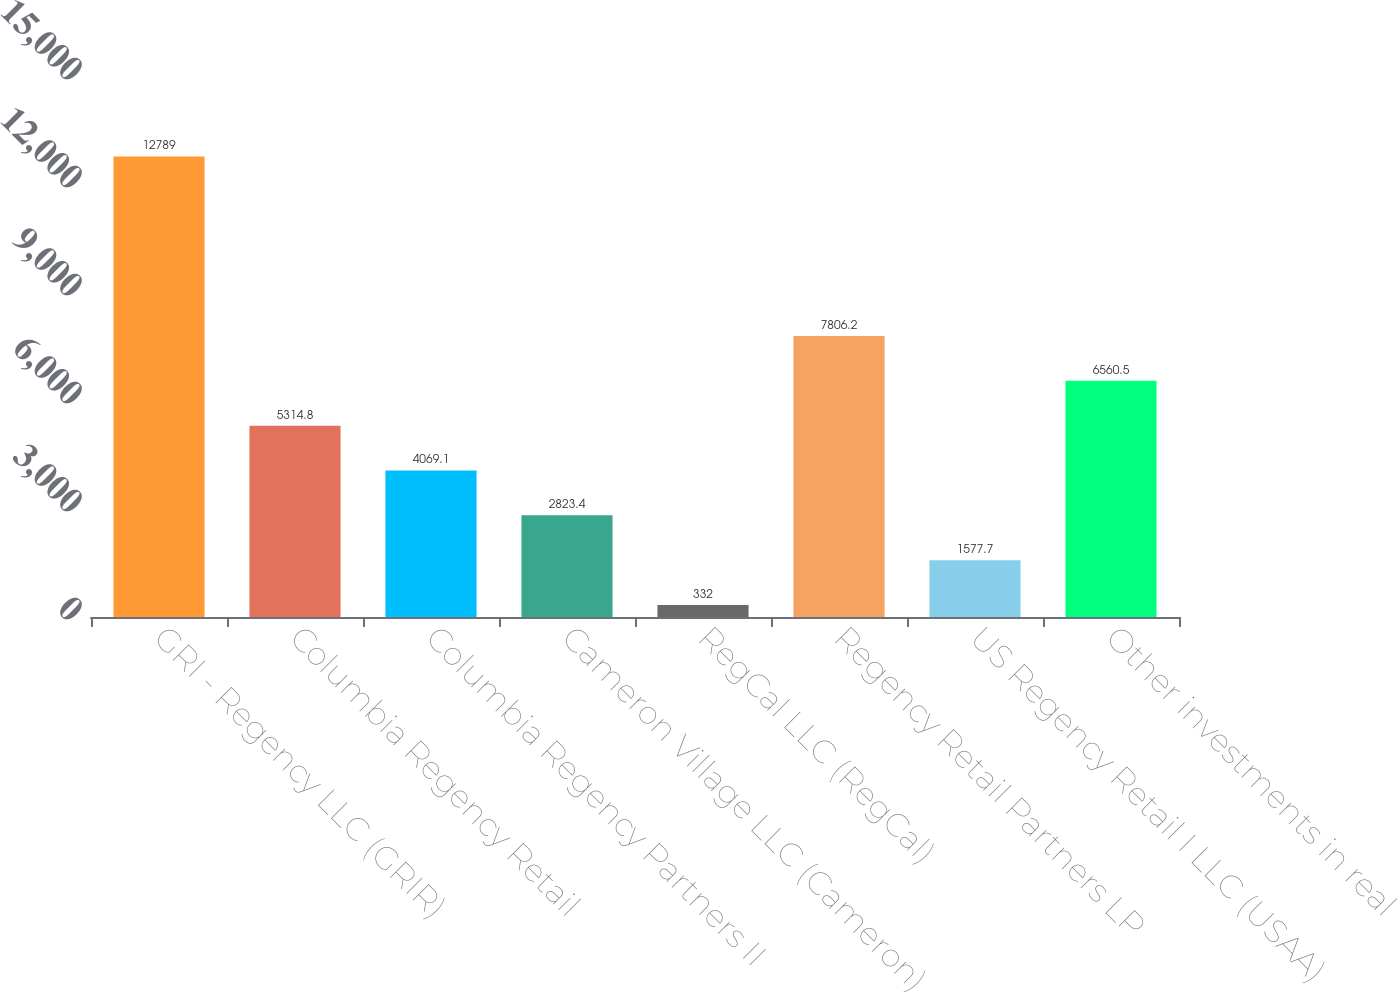<chart> <loc_0><loc_0><loc_500><loc_500><bar_chart><fcel>GRI - Regency LLC (GRIR)<fcel>Columbia Regency Retail<fcel>Columbia Regency Partners II<fcel>Cameron Village LLC (Cameron)<fcel>RegCal LLC (RegCal)<fcel>Regency Retail Partners LP<fcel>US Regency Retail I LLC (USAA)<fcel>Other investments in real<nl><fcel>12789<fcel>5314.8<fcel>4069.1<fcel>2823.4<fcel>332<fcel>7806.2<fcel>1577.7<fcel>6560.5<nl></chart> 